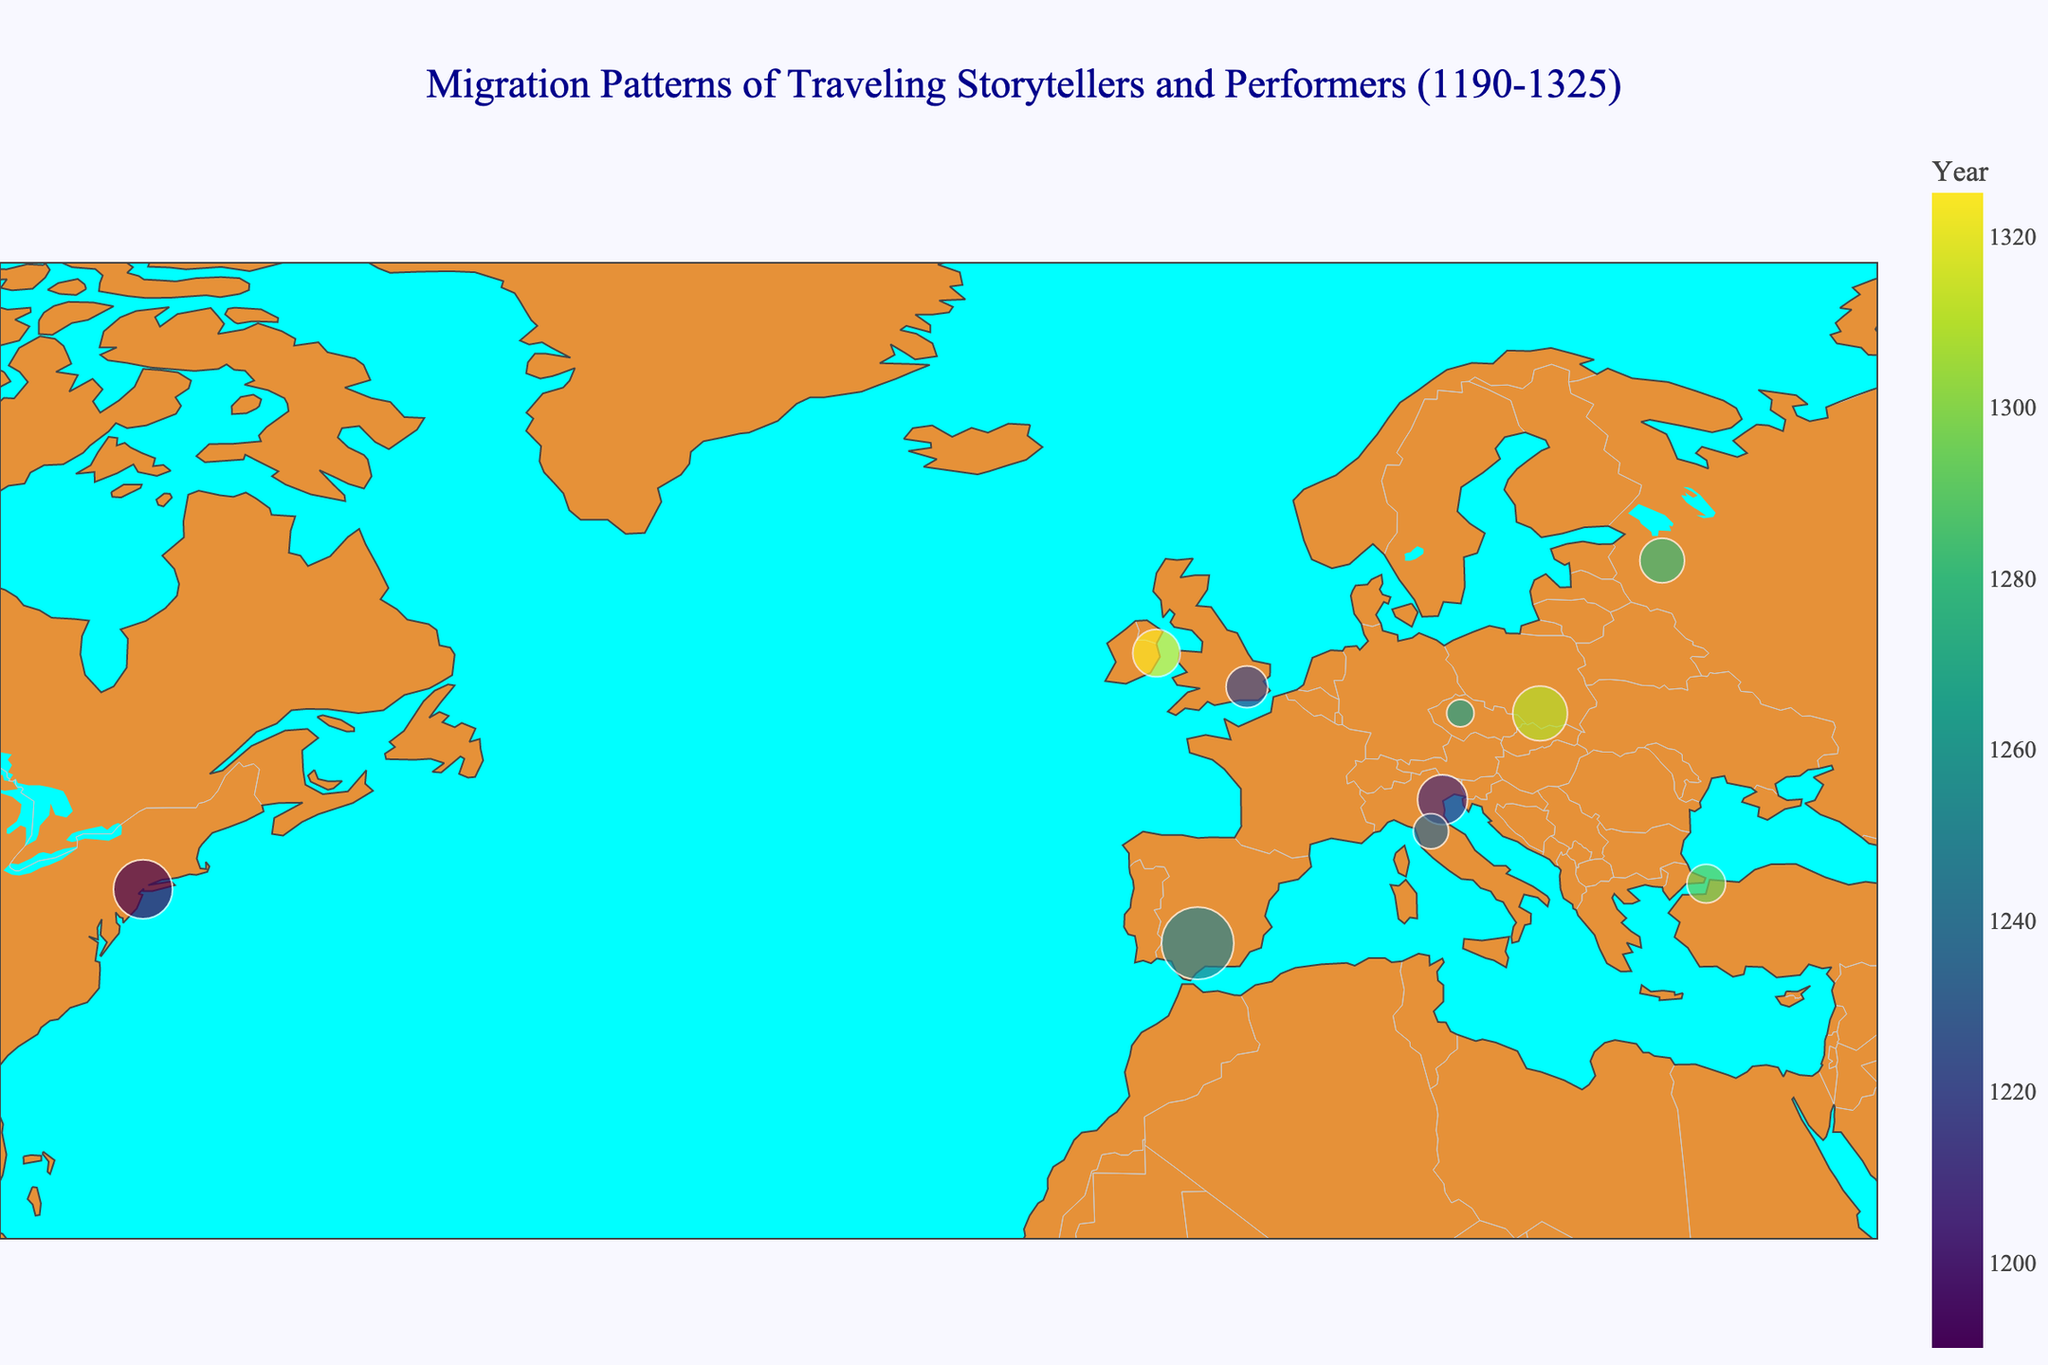Which location hosted the event in the year 1295? The year 1295 is noted with an event hosted in Constantinople. This can be identified by hovering over the data point which indicates Constantinople in 1295.
Answer: Constantinople How many days did the Spring Festival in Paris last? By hovering over the data point in Paris, it shows that the Spring Festival lasted for 14 days.
Answer: 14 Which event lasted the longest and how many days did it last? Checking the duration of days for each event, the longest-lasting event was the Caliphate Anniversary in Córdoba, which lasted for 21 days.
Answer: Caliphate Anniversary, 21 days Which two locations were visited closest in terms of years? By observing the years, Florence was visited in 1235 and Córdoba in 1250, resulting in a 15-year gap. This is the smallest gap between two subsequent location visits.
Answer: Florence and Córdoba Which location had the smallest event duration? Hovering over the location markers reveals that the smallest event duration was in Prague, where the Coronation Ceremony lasted for 3 days.
Answer: Prague What is the average event duration across all locations? Summing up all event durations: 14 + 10 + 7 + 5 + 21 + 3 + 8 + 6 + 12 + 9 = 95 days. Dividing by the number of events (10): 95/10 = 9.5 days.
Answer: 9.5 days Which location had an event in the earliest year and what year was it? The data point with the earliest year is Paris, which held an event in 1190.
Answer: Paris, 1190 Compare the size of the events in Venice and London. Which lasted longer and by how many days? Venice's event lasted for 10 days, while London's event lasted for 7 days. Venice's event lasted 3 days longer than London’s event.
Answer: Venice, 3 days What geographic pattern do you observe related to the color scale used for the years? The color scale moves from darker colors for earlier years to lighter colors for later years, indicating a chronological sequence of events across different locations.
Answer: Sequentially color-coded Identify the event in Krakow and its year. Hovering over the data point in Krakow reveals the event was the University Foundation which took place in 1310.
Answer: University Foundation, 1310 